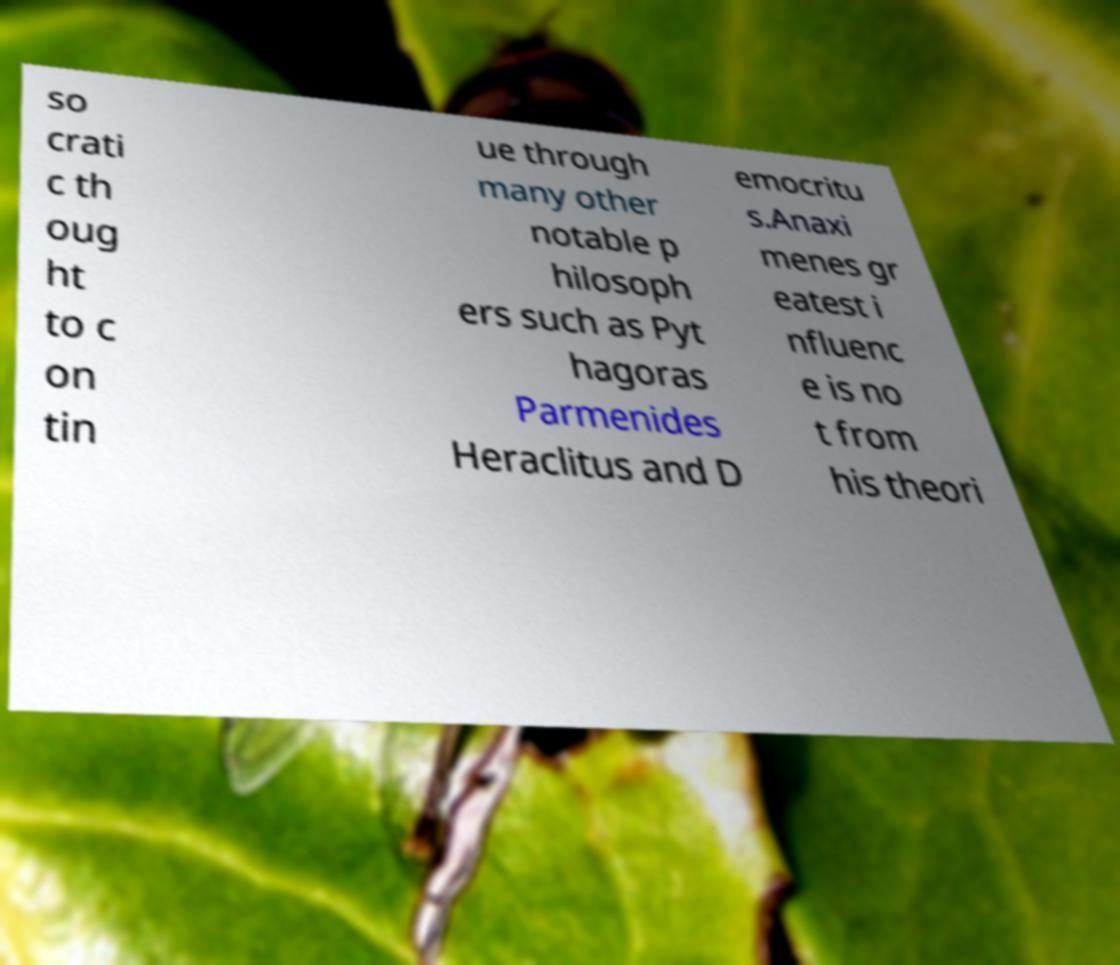Please read and relay the text visible in this image. What does it say? so crati c th oug ht to c on tin ue through many other notable p hilosoph ers such as Pyt hagoras Parmenides Heraclitus and D emocritu s.Anaxi menes gr eatest i nfluenc e is no t from his theori 